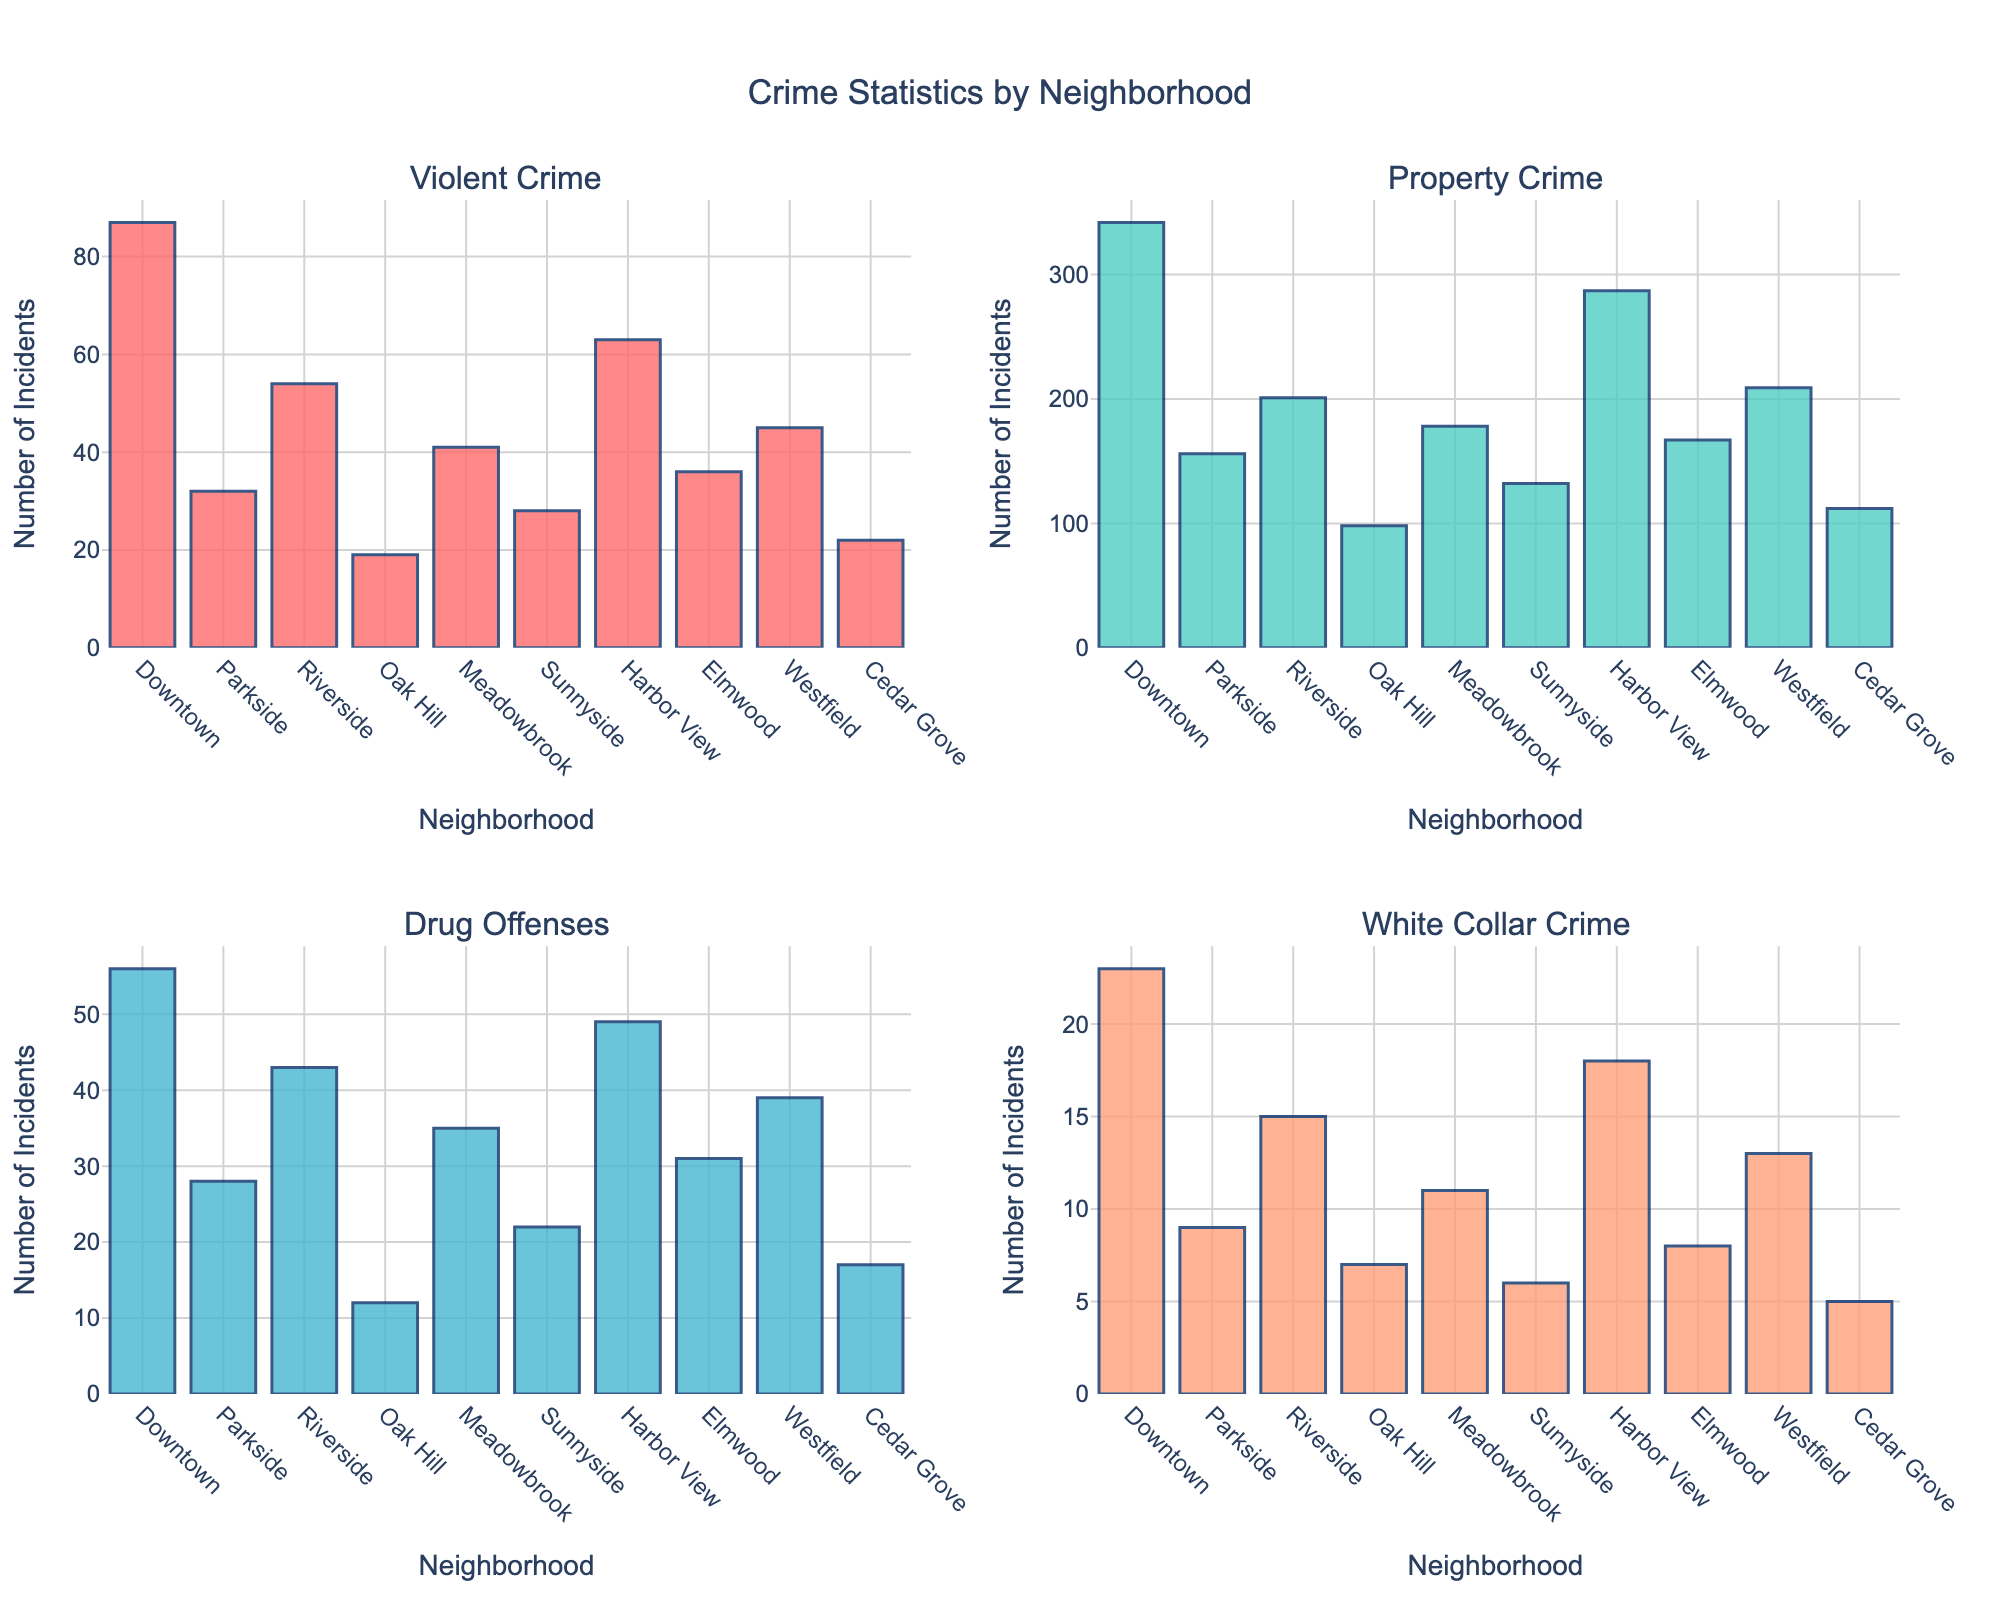Which neighborhood has the highest number of Property Crimes? The Property Crimes subplot shows Harbor View with the highest number of incidents.
Answer: Harbor View How many Violent Crimes were reported in Parkside and Sunnyside combined? According to the Violent Crimes subplot, Parkside has 32 incidents, and Sunnyside has 28 incidents. Adding these together: 32 + 28 = 60
Answer: 60 Which crime category has the lowest number of incidents in Cedar Grove? By looking at the subplots, White Collar Crime in Cedar Grove has the lowest number with 5 incidents.
Answer: White Collar Crime What is the difference in Drug Offense incidents between Downtown and Oak Hill? The Drug Offenses subplot shows Downtown with 56 incidents and Oak Hill with 12 incidents. The difference is 56 - 12 = 44.
Answer: 44 In which Neighborhood are the number of Property Crimes and Drug Offenses closest? By comparing the Property Crimes and Drug Offenses subplots, Elmwood has 167 Property Crimes and 31 Drug Offenses. The numbers are close in comparison to other neighborhoods.
Answer: Elmwood What is the total number of Violent Crimes reported across all neighborhoods? Adding up the Violent Crimes incidents from each neighborhood, we get: 87 + 32 + 54 + 19 + 41 + 28 + 63 + 36 + 45 + 22 = 427.
Answer: 427 Which neighborhood reports the highest number of Drug Offenses? The Drug Offenses subplot shows Downtown has the highest number with 56 incidents.
Answer: Downtown Which neighborhood has the least White Collar Crime incidents? The White Collar Crime subplot indicates Sunnyside has the least incidents with only 6 reported.
Answer: Sunnyside How does the number of Violent Crimes in Downtown compare to Harbor View? Violent Crimes subplot shows Downtown with 87 incidents and Harbor View with 63 incidents. Downtown has more incidents than Harbor View.
Answer: Downtown has more 